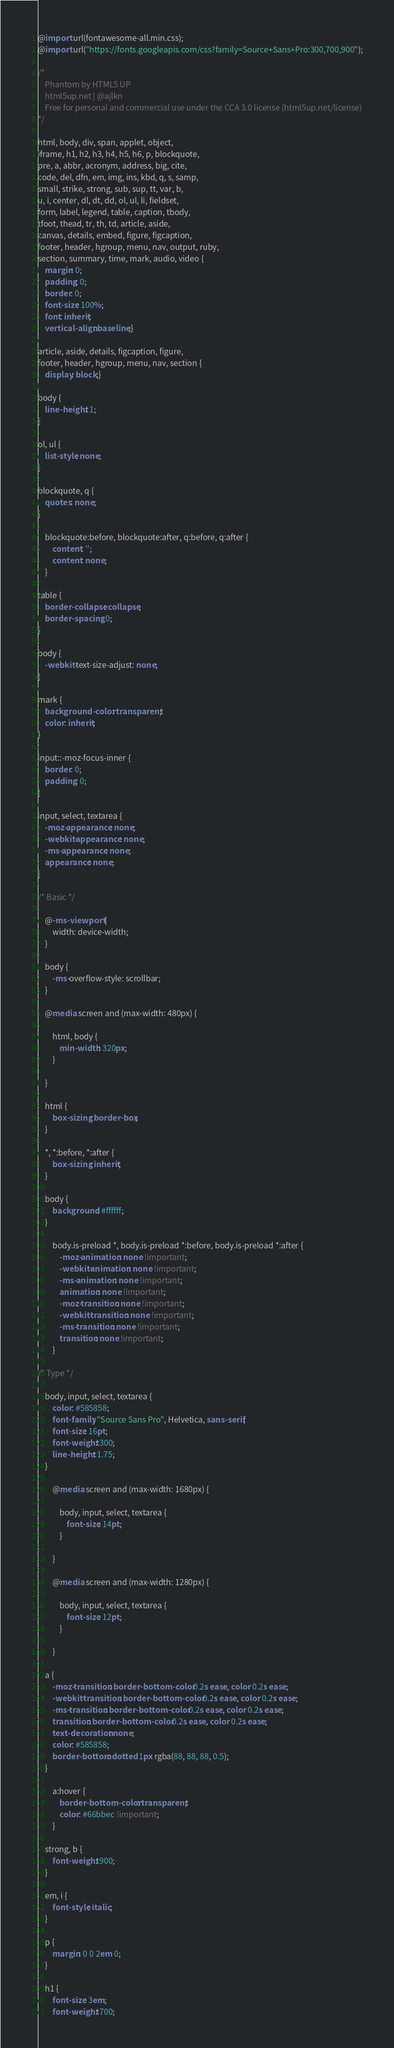<code> <loc_0><loc_0><loc_500><loc_500><_CSS_>@import url(fontawesome-all.min.css);
@import url("https://fonts.googleapis.com/css?family=Source+Sans+Pro:300,700,900");

/*
	Phantom by HTML5 UP
	html5up.net | @ajlkn
	Free for personal and commercial use under the CCA 3.0 license (html5up.net/license)
*/

html, body, div, span, applet, object,
iframe, h1, h2, h3, h4, h5, h6, p, blockquote,
pre, a, abbr, acronym, address, big, cite,
code, del, dfn, em, img, ins, kbd, q, s, samp,
small, strike, strong, sub, sup, tt, var, b,
u, i, center, dl, dt, dd, ol, ul, li, fieldset,
form, label, legend, table, caption, tbody,
tfoot, thead, tr, th, td, article, aside,
canvas, details, embed, figure, figcaption,
footer, header, hgroup, menu, nav, output, ruby,
section, summary, time, mark, audio, video {
	margin: 0;
	padding: 0;
	border: 0;
	font-size: 100%;
	font: inherit;
	vertical-align: baseline;}

article, aside, details, figcaption, figure,
footer, header, hgroup, menu, nav, section {
	display: block;}

body {
	line-height: 1;
}

ol, ul {
	list-style: none;
}

blockquote, q {
	quotes: none;
}

	blockquote:before, blockquote:after, q:before, q:after {
		content: '';
		content: none;
	}

table {
	border-collapse: collapse;
	border-spacing: 0;
}

body {
	-webkit-text-size-adjust: none;
}

mark {
	background-color: transparent;
	color: inherit;
}

input::-moz-focus-inner {
	border: 0;
	padding: 0;
}

input, select, textarea {
	-moz-appearance: none;
	-webkit-appearance: none;
	-ms-appearance: none;
	appearance: none;
}

/* Basic */

	@-ms-viewport {
		width: device-width;
	}

	body {
		-ms-overflow-style: scrollbar;
	}

	@media screen and (max-width: 480px) {

		html, body {
			min-width: 320px;
		}

	}

	html {
		box-sizing: border-box;
	}

	*, *:before, *:after {
		box-sizing: inherit;
	}

	body {
		background: #ffffff;
	}

		body.is-preload *, body.is-preload *:before, body.is-preload *:after {
			-moz-animation: none !important;
			-webkit-animation: none !important;
			-ms-animation: none !important;
			animation: none !important;
			-moz-transition: none !important;
			-webkit-transition: none !important;
			-ms-transition: none !important;
			transition: none !important;
		}

/* Type */

	body, input, select, textarea {
		color: #585858;
		font-family: "Source Sans Pro", Helvetica, sans-serif;
		font-size: 16pt;
		font-weight: 300;
		line-height: 1.75;
	}

		@media screen and (max-width: 1680px) {

			body, input, select, textarea {
				font-size: 14pt;
			}

		}

		@media screen and (max-width: 1280px) {

			body, input, select, textarea {
				font-size: 12pt;
			}

		}

	a {
		-moz-transition: border-bottom-color 0.2s ease, color 0.2s ease;
		-webkit-transition: border-bottom-color 0.2s ease, color 0.2s ease;
		-ms-transition: border-bottom-color 0.2s ease, color 0.2s ease;
		transition: border-bottom-color 0.2s ease, color 0.2s ease;
		text-decoration: none;
		color: #585858;
		border-bottom: dotted 1px rgba(88, 88, 88, 0.5);
	}

		a:hover {
			border-bottom-color: transparent;
			color: #66bbec !important;
		}

	strong, b {
		font-weight: 900;
	}

	em, i {
		font-style: italic;
	}

	p {
		margin: 0 0 2em 0;
	}

	h1 {
		font-size: 3em;
		font-weight: 700;</code> 